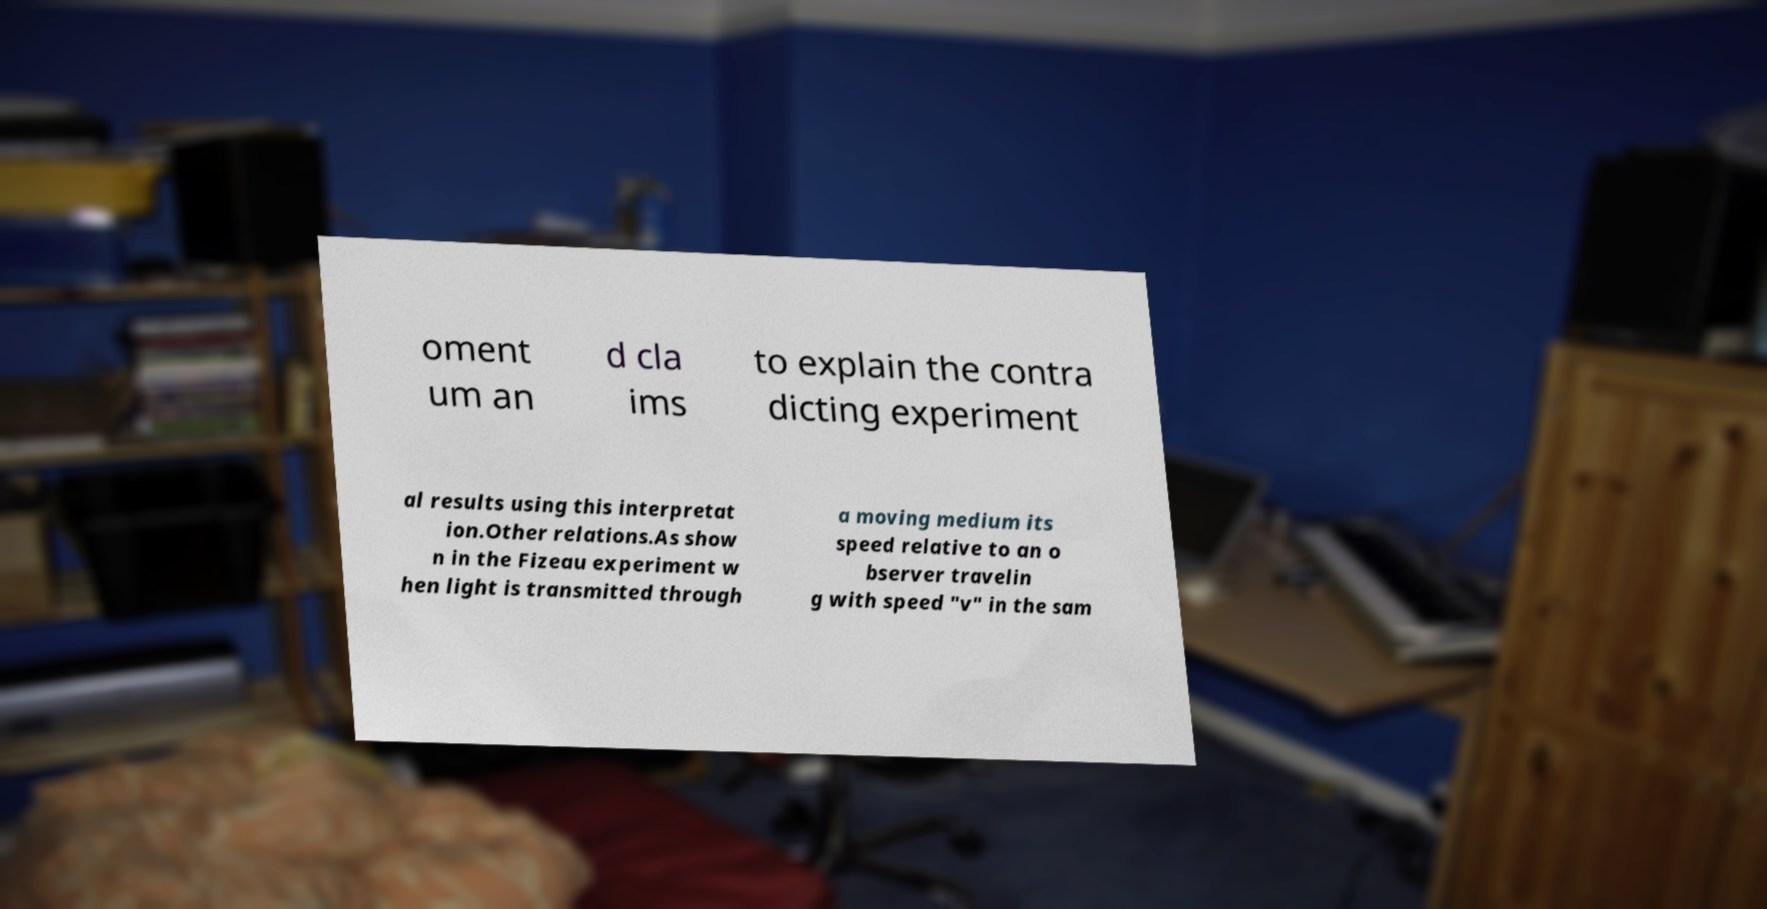What messages or text are displayed in this image? I need them in a readable, typed format. oment um an d cla ims to explain the contra dicting experiment al results using this interpretat ion.Other relations.As show n in the Fizeau experiment w hen light is transmitted through a moving medium its speed relative to an o bserver travelin g with speed "v" in the sam 